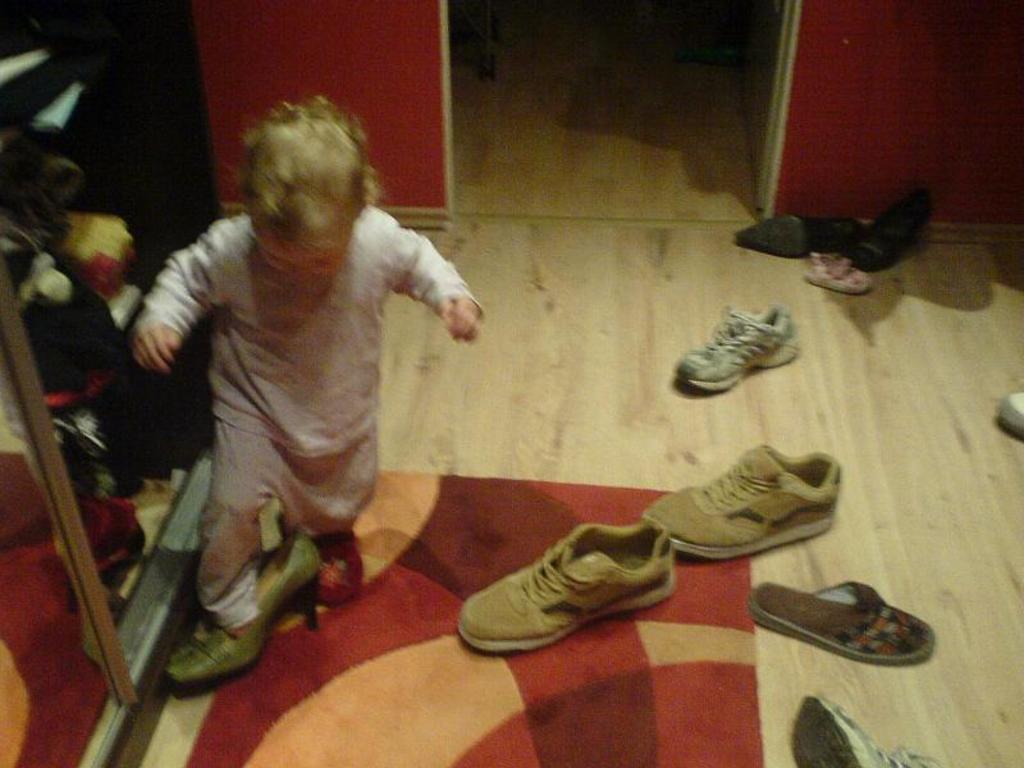In one or two sentences, can you explain what this image depicts? In this picture there is a small girl on the left side of the image and there are footwear and a rug on the floor, it seems to be there are cupboards on the left side of the image. 